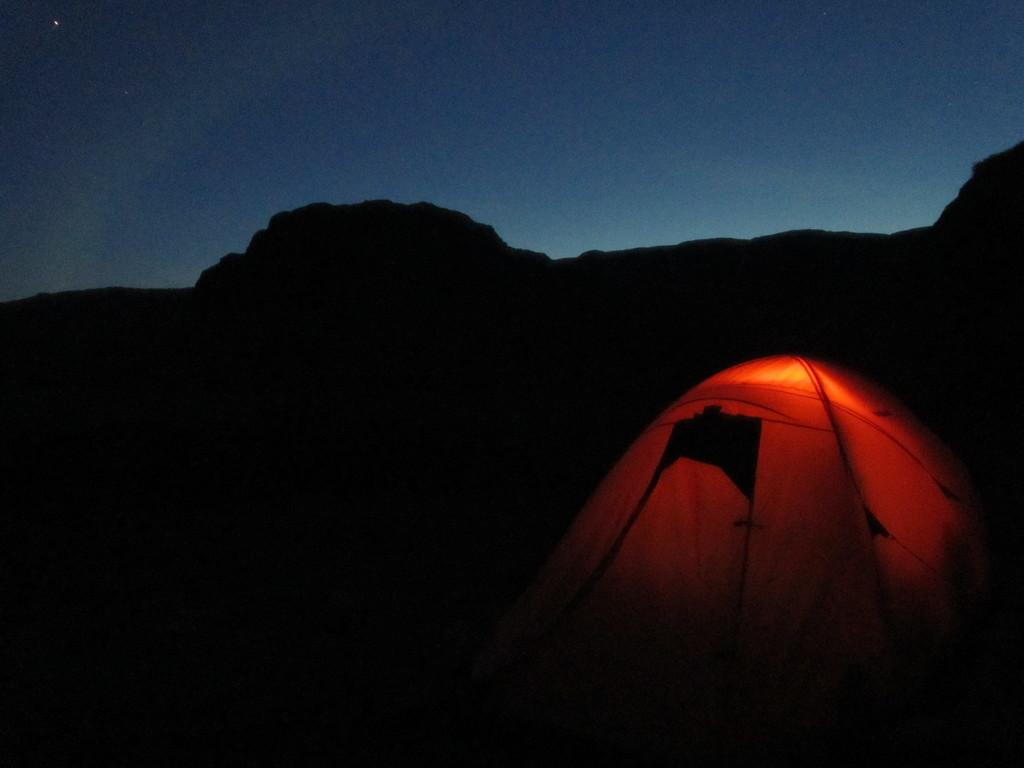What type of shelter is present in the image? There is a camping tent in the image. What can be seen above the camping tent in the image? The sky is visible at the top of the image. Where is the park located in the image? There is no park present in the image; it only features a camping tent and the sky. 